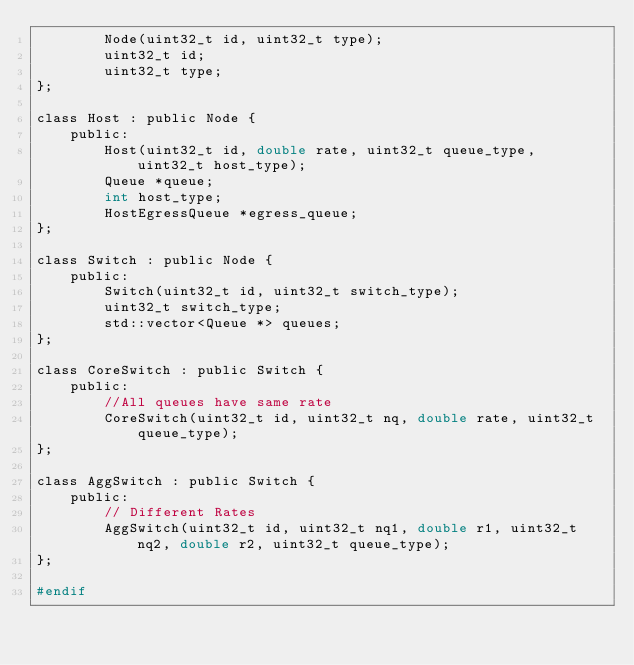Convert code to text. <code><loc_0><loc_0><loc_500><loc_500><_C_>        Node(uint32_t id, uint32_t type);
        uint32_t id;
        uint32_t type;
};

class Host : public Node {
    public:
        Host(uint32_t id, double rate, uint32_t queue_type, uint32_t host_type);
        Queue *queue;
        int host_type;
        HostEgressQueue *egress_queue;
};

class Switch : public Node {
    public:
        Switch(uint32_t id, uint32_t switch_type);
        uint32_t switch_type;
        std::vector<Queue *> queues;
};

class CoreSwitch : public Switch {
    public:
        //All queues have same rate
        CoreSwitch(uint32_t id, uint32_t nq, double rate, uint32_t queue_type);
};

class AggSwitch : public Switch {
    public:
        // Different Rates
        AggSwitch(uint32_t id, uint32_t nq1, double r1, uint32_t nq2, double r2, uint32_t queue_type);
};

#endif
</code> 